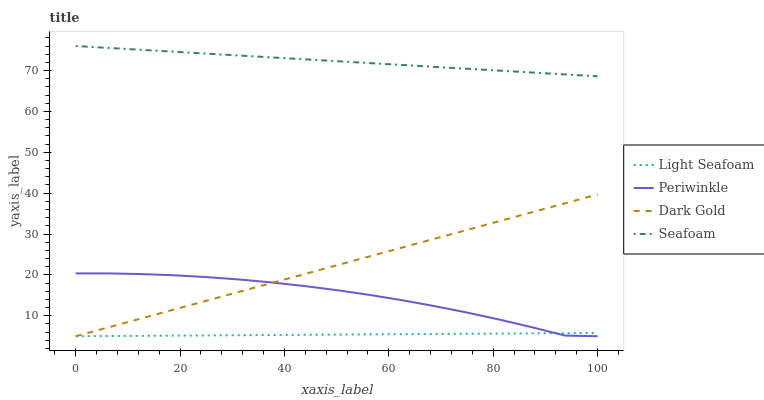Does Periwinkle have the minimum area under the curve?
Answer yes or no. No. Does Periwinkle have the maximum area under the curve?
Answer yes or no. No. Is Seafoam the smoothest?
Answer yes or no. No. Is Seafoam the roughest?
Answer yes or no. No. Does Seafoam have the lowest value?
Answer yes or no. No. Does Periwinkle have the highest value?
Answer yes or no. No. Is Light Seafoam less than Seafoam?
Answer yes or no. Yes. Is Seafoam greater than Periwinkle?
Answer yes or no. Yes. Does Light Seafoam intersect Seafoam?
Answer yes or no. No. 